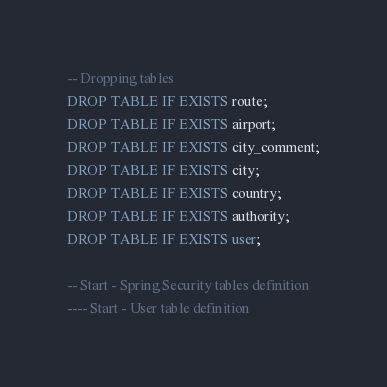Convert code to text. <code><loc_0><loc_0><loc_500><loc_500><_SQL_>-- Dropping tables
DROP TABLE IF EXISTS route;
DROP TABLE IF EXISTS airport;
DROP TABLE IF EXISTS city_comment;
DROP TABLE IF EXISTS city;
DROP TABLE IF EXISTS country;
DROP TABLE IF EXISTS authority;
DROP TABLE IF EXISTS user;

-- Start - Spring Security tables definition
---- Start - User table definition
</code> 